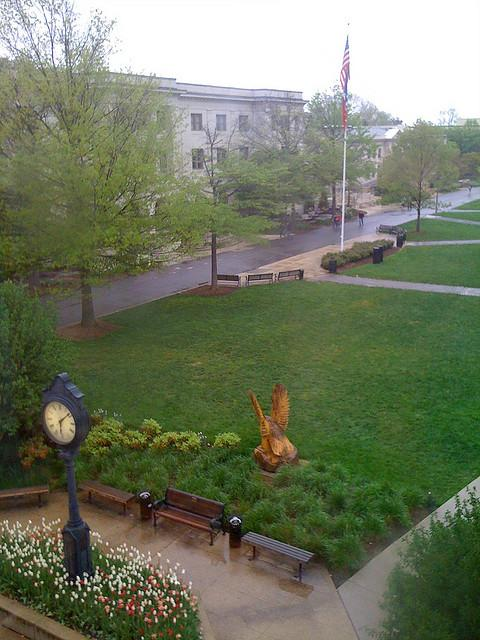What might someone need if they are walking by this clock?

Choices:
A) umbrella
B) dog
C) watch
D) snacks umbrella 